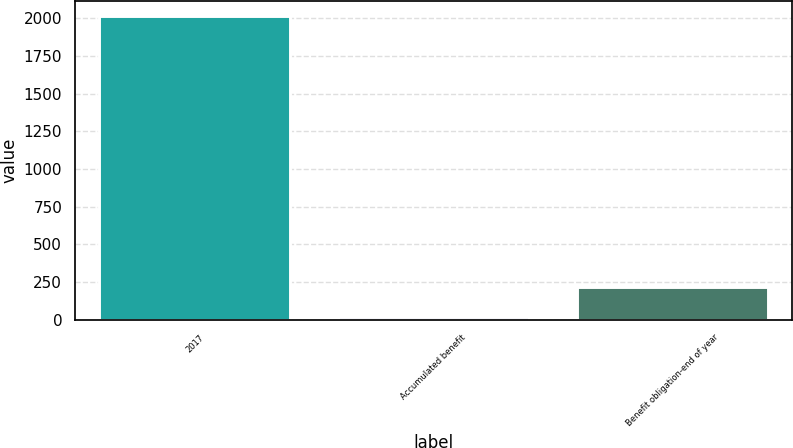Convert chart to OTSL. <chart><loc_0><loc_0><loc_500><loc_500><bar_chart><fcel>2017<fcel>Accumulated benefit<fcel>Benefit obligation-end of year<nl><fcel>2016<fcel>16<fcel>216<nl></chart> 